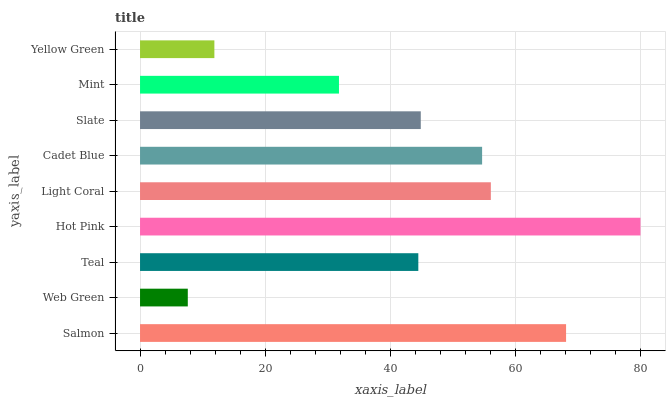Is Web Green the minimum?
Answer yes or no. Yes. Is Hot Pink the maximum?
Answer yes or no. Yes. Is Teal the minimum?
Answer yes or no. No. Is Teal the maximum?
Answer yes or no. No. Is Teal greater than Web Green?
Answer yes or no. Yes. Is Web Green less than Teal?
Answer yes or no. Yes. Is Web Green greater than Teal?
Answer yes or no. No. Is Teal less than Web Green?
Answer yes or no. No. Is Slate the high median?
Answer yes or no. Yes. Is Slate the low median?
Answer yes or no. Yes. Is Hot Pink the high median?
Answer yes or no. No. Is Teal the low median?
Answer yes or no. No. 